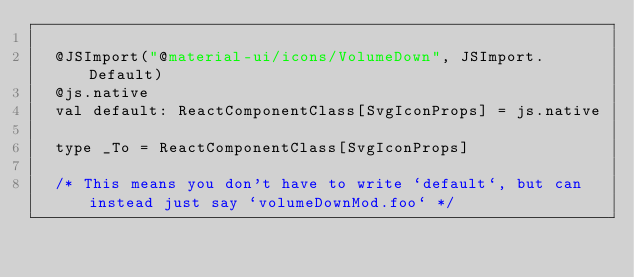Convert code to text. <code><loc_0><loc_0><loc_500><loc_500><_Scala_>  
  @JSImport("@material-ui/icons/VolumeDown", JSImport.Default)
  @js.native
  val default: ReactComponentClass[SvgIconProps] = js.native
  
  type _To = ReactComponentClass[SvgIconProps]
  
  /* This means you don't have to write `default`, but can instead just say `volumeDownMod.foo` */</code> 